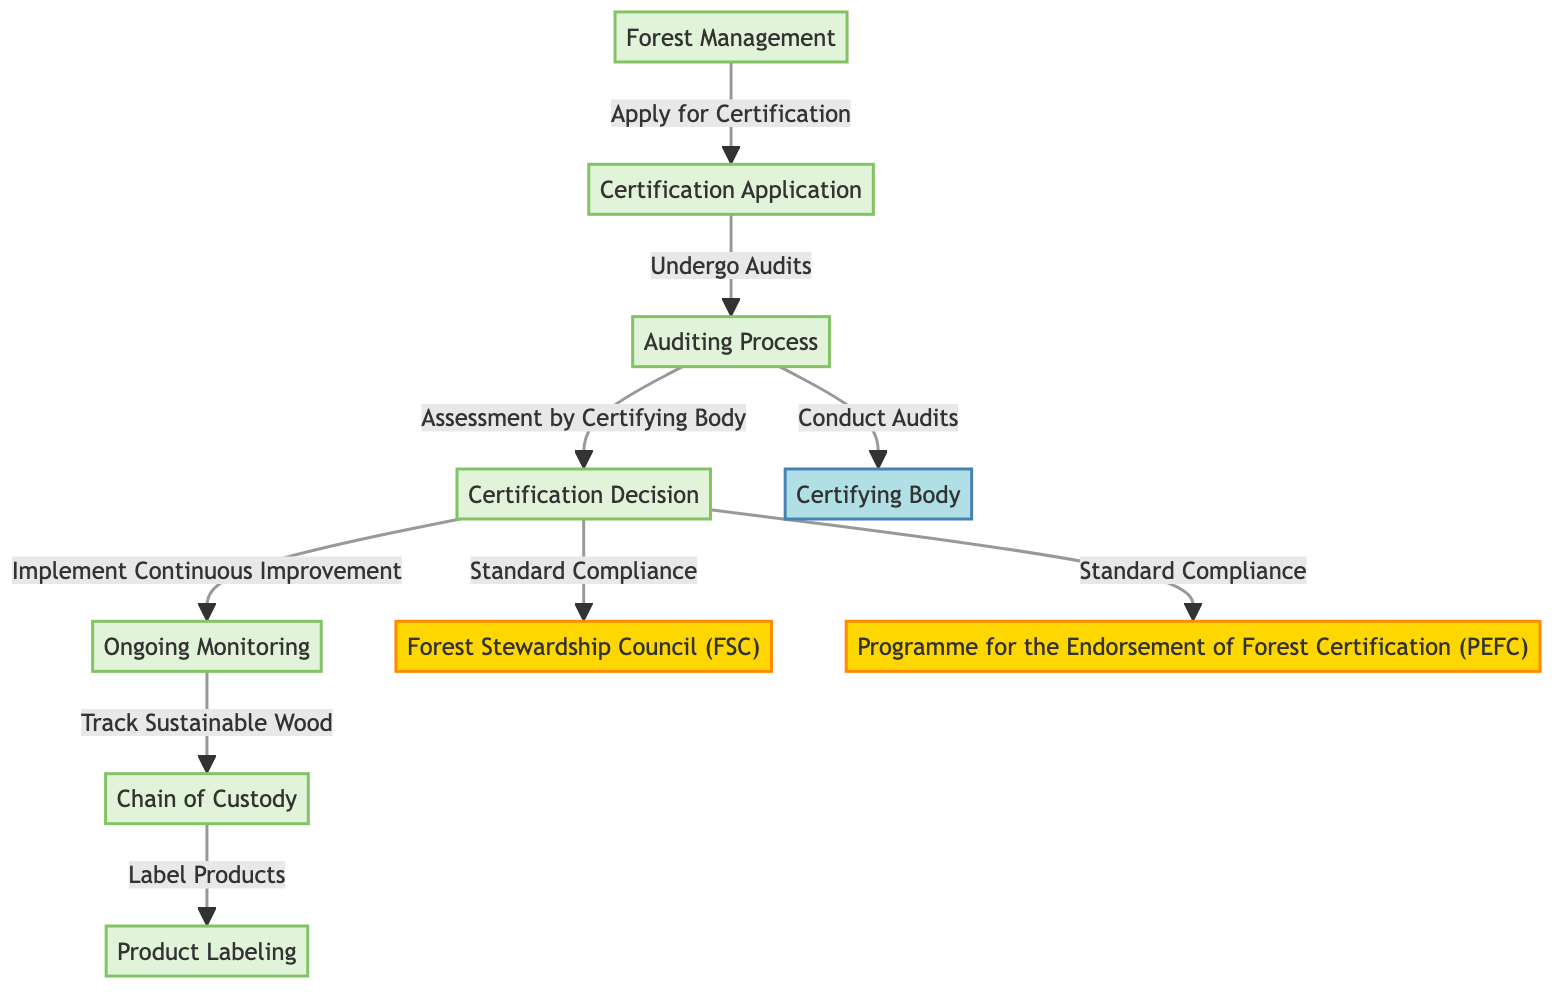What is the first step in the certification process for sustainably-sourced wood products? The diagram shows that the first step is "Forest Management." This node is positioned at the beginning of the flowchart, clearly indicating that it initiates the certification process.
Answer: Forest Management How many certification bodies are mentioned in the diagram? The diagram includes two certification bodies: "Forest Stewardship Council (FSC)" and "Programme for the Endorsement of Forest Certification (PEFC)." The flowchart shows two separate connections leading to these bodies for standard compliance.
Answer: Two What follows after the "Certification Application"? In the flowchart, the node labeled "Auditing Process" directly follows the "Certification Application" node, indicating that this is the next step in the sequence.
Answer: Auditing Process What is the role of the "Certifying Body" in the process? According to the diagram, the "Certifying Body" conducts audits as part of the "Auditing Process." This indicates that their role is to assess compliance during this step in the certification flow.
Answer: Conduct Audits What is the final step in the certification process for sustainably-sourced wood products? The process ends with the "Product Labeling" node, which is the last step in the sequence leading from "Chain of Custody," indicating the completion of the certification process.
Answer: Product Labeling How does "Ongoing Monitoring" relate to "Certification Decision"? The diagram shows that "Ongoing Monitoring" follows directly from "Certification Decision," and it indicates a relationship where continuous improvement is implemented based on the decision made in that step.
Answer: Continuous Improvement What are the two compliance standards shown in the certification process? The diagram displays "Forest Stewardship Council (FSC)" and "Programme for the Endorsement of Forest Certification (PEFC)" as the two standards for compliance related to the "Certification Decision" node.
Answer: FSC and PEFC What process comes immediately before "Chain of Custody"? The node "Ongoing Monitoring" is shown as the step that comes immediately before "Chain of Custody" in the flowchart, indicating that tracking sustainable wood happens after ongoing monitoring steps are implemented.
Answer: Ongoing Monitoring 